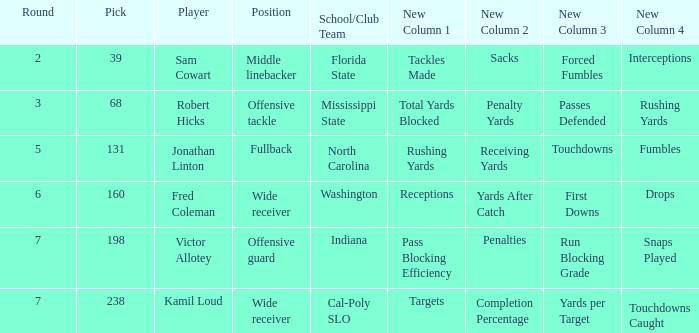Which Round has a School/Club Team of north carolina, and a Pick larger than 131? 0.0. 